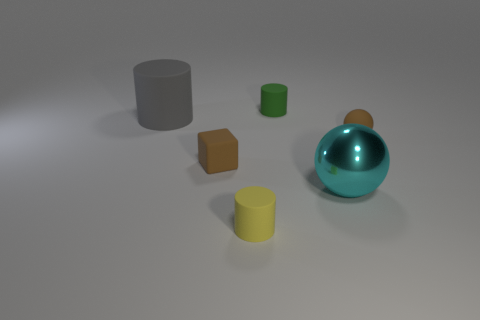Is the number of things that are on the right side of the small green object greater than the number of large cyan things that are right of the shiny ball?
Provide a succinct answer. Yes. The yellow thing that is made of the same material as the block is what shape?
Offer a very short reply. Cylinder. Are there more small brown rubber spheres behind the gray matte cylinder than cyan metal things?
Make the answer very short. No. What number of big things are the same color as the big rubber cylinder?
Your answer should be compact. 0. How many other things are the same color as the big metallic ball?
Your answer should be compact. 0. Is the number of large red shiny cylinders greater than the number of yellow cylinders?
Your answer should be very brief. No. What material is the tiny yellow object?
Your response must be concise. Rubber. Does the thing to the left of the matte cube have the same size as the metal sphere?
Your answer should be very brief. Yes. How big is the brown matte sphere that is on the right side of the small green cylinder?
Your answer should be very brief. Small. Is there any other thing that is made of the same material as the big gray cylinder?
Offer a very short reply. Yes. 